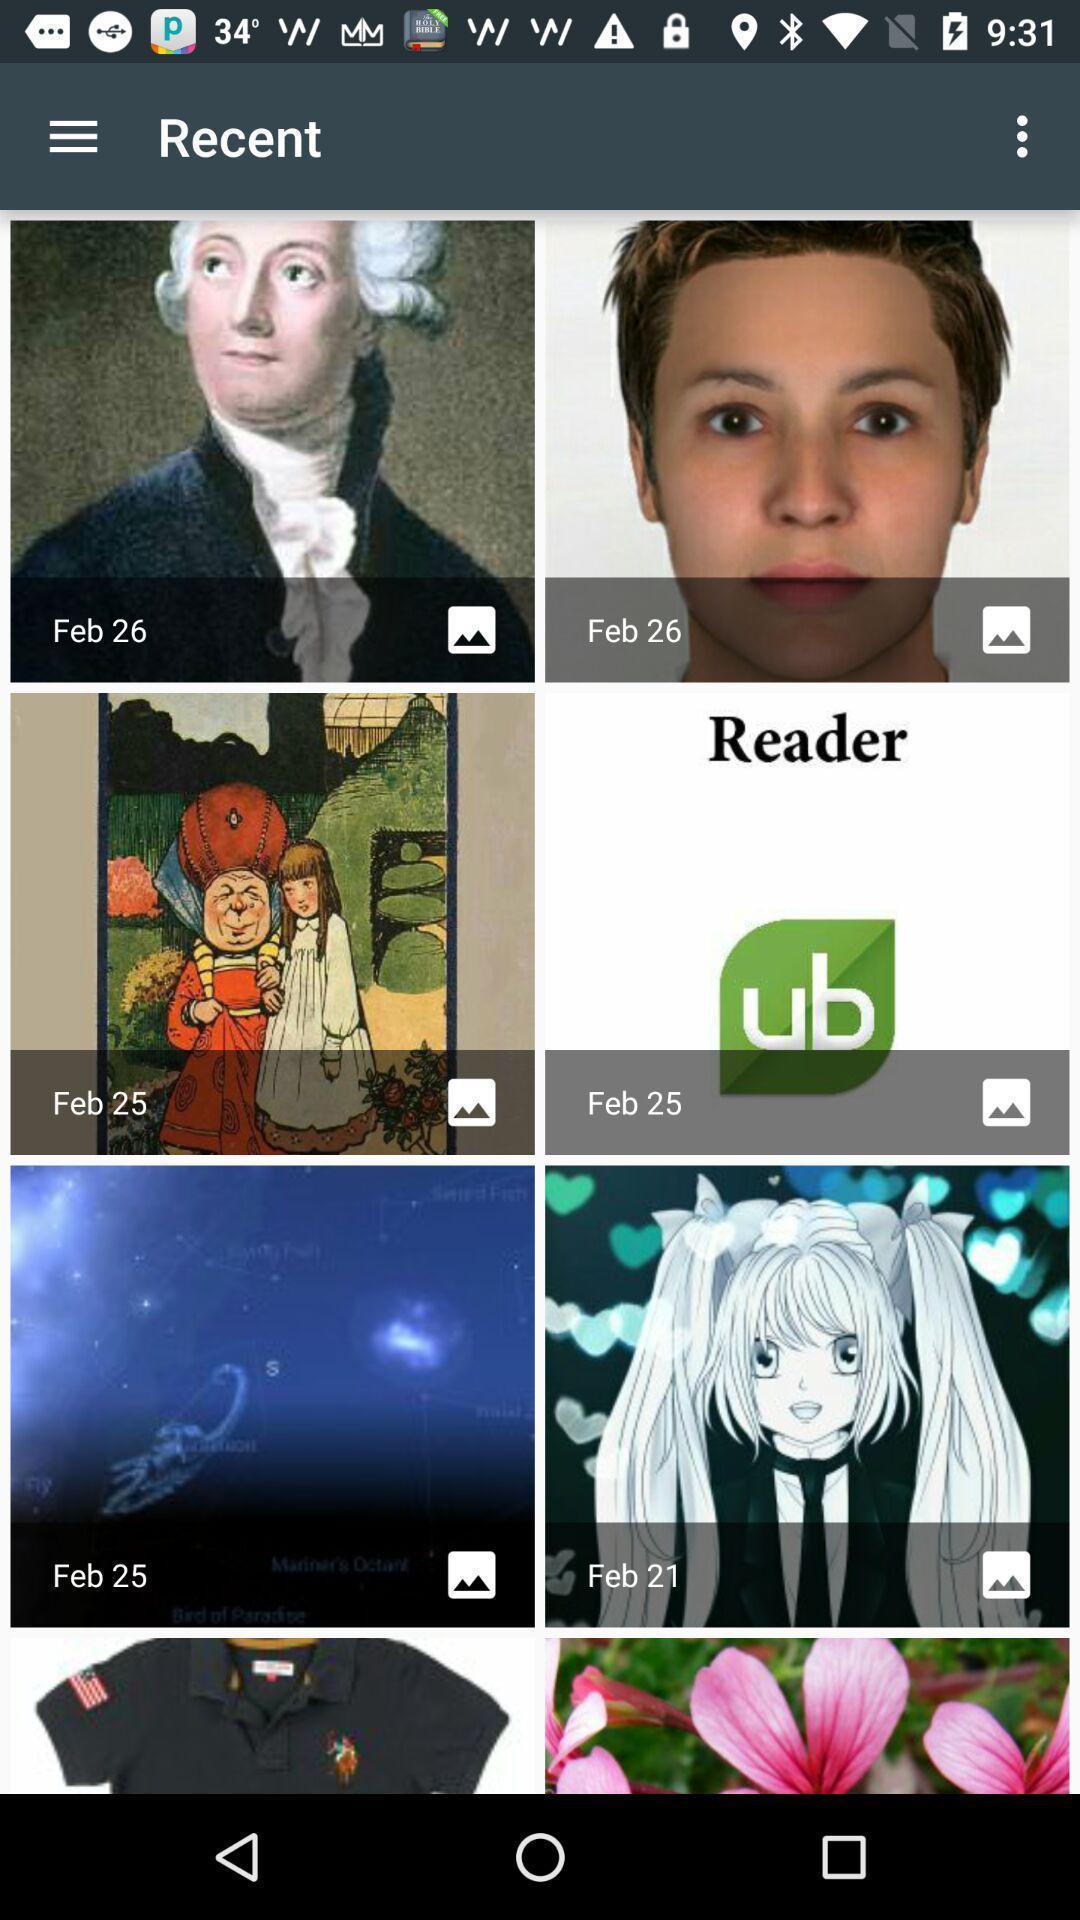Explain what's happening in this screen capture. Page showing various images in an image editing app. 